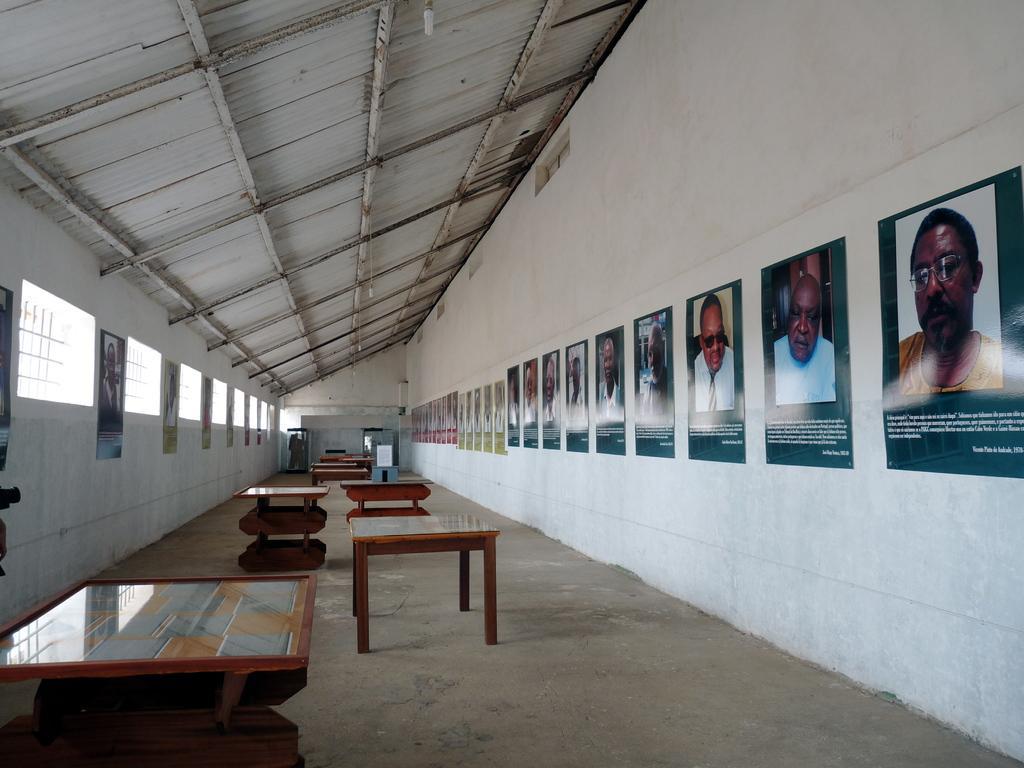Can you describe this image briefly? This is a room, in this room we can see some table and some pictures attached to the wall and at the background of the image there is also wall. 